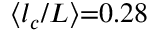Convert formula to latex. <formula><loc_0><loc_0><loc_500><loc_500>\langle { l _ { c } } / L \rangle { = } 0 . 2 8</formula> 